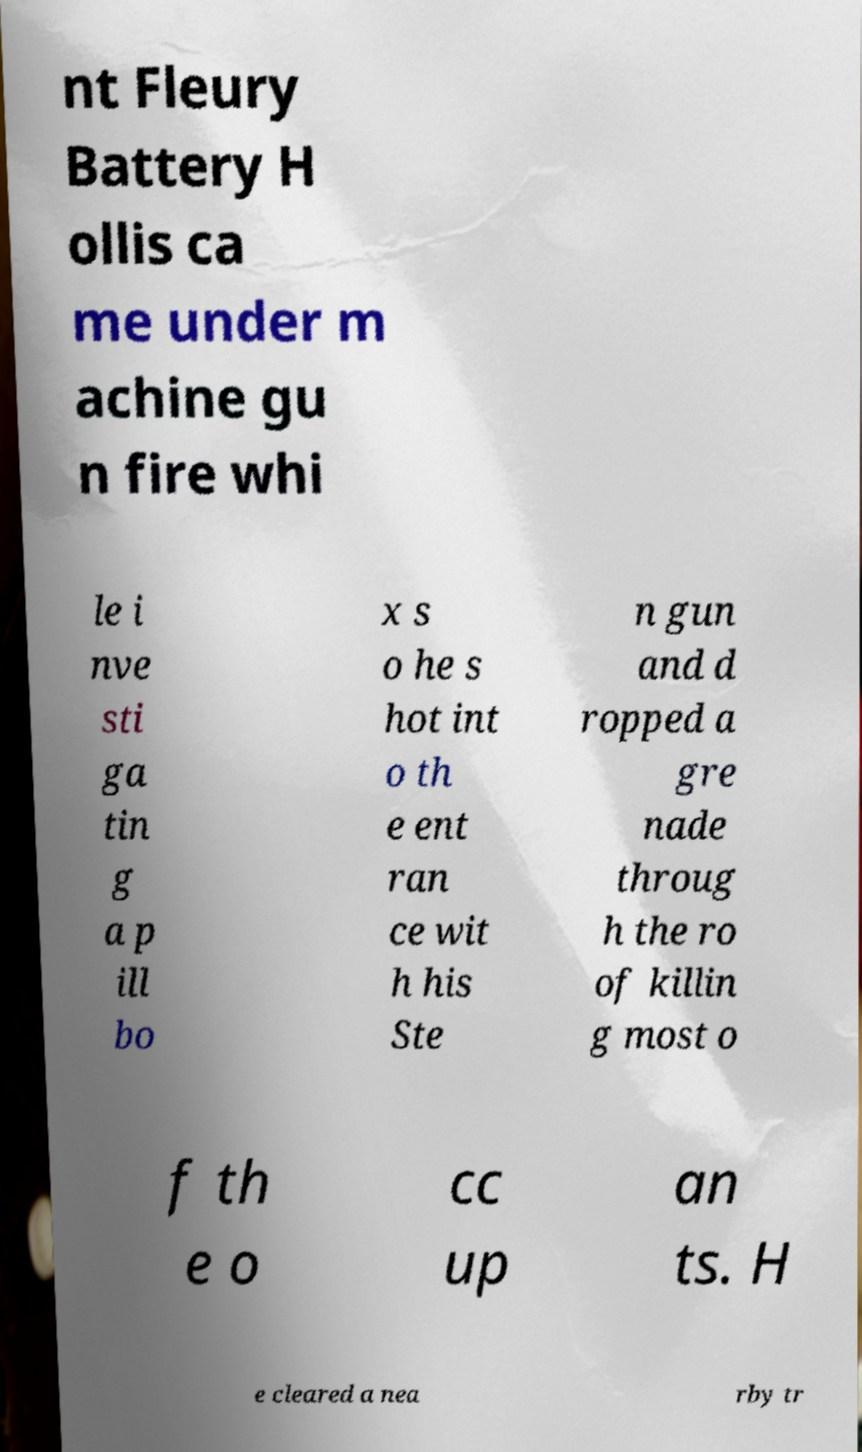Can you accurately transcribe the text from the provided image for me? nt Fleury Battery H ollis ca me under m achine gu n fire whi le i nve sti ga tin g a p ill bo x s o he s hot int o th e ent ran ce wit h his Ste n gun and d ropped a gre nade throug h the ro of killin g most o f th e o cc up an ts. H e cleared a nea rby tr 